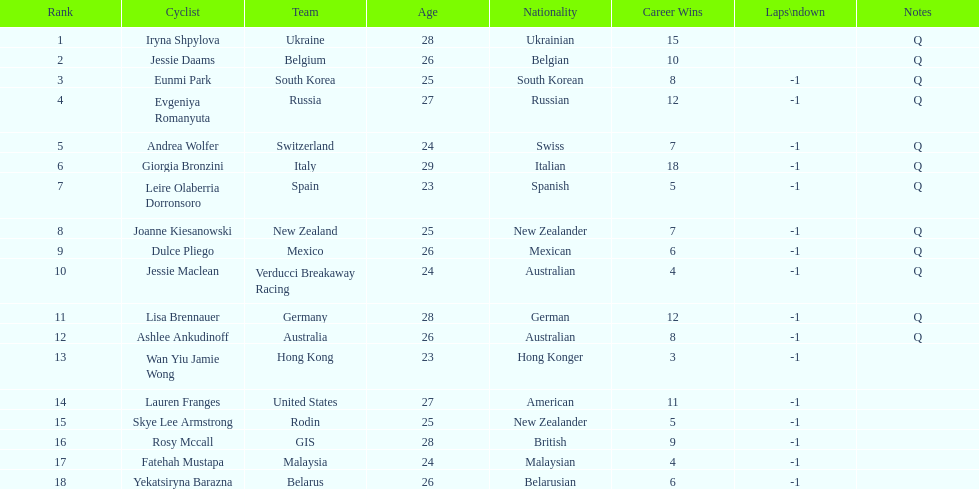What two cyclists come from teams with no laps down? Iryna Shpylova, Jessie Daams. 